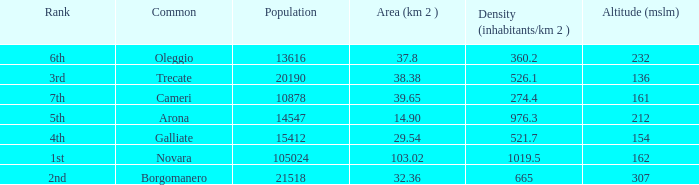What is the minimum altitude (mslm) in all the commons? 136.0. 